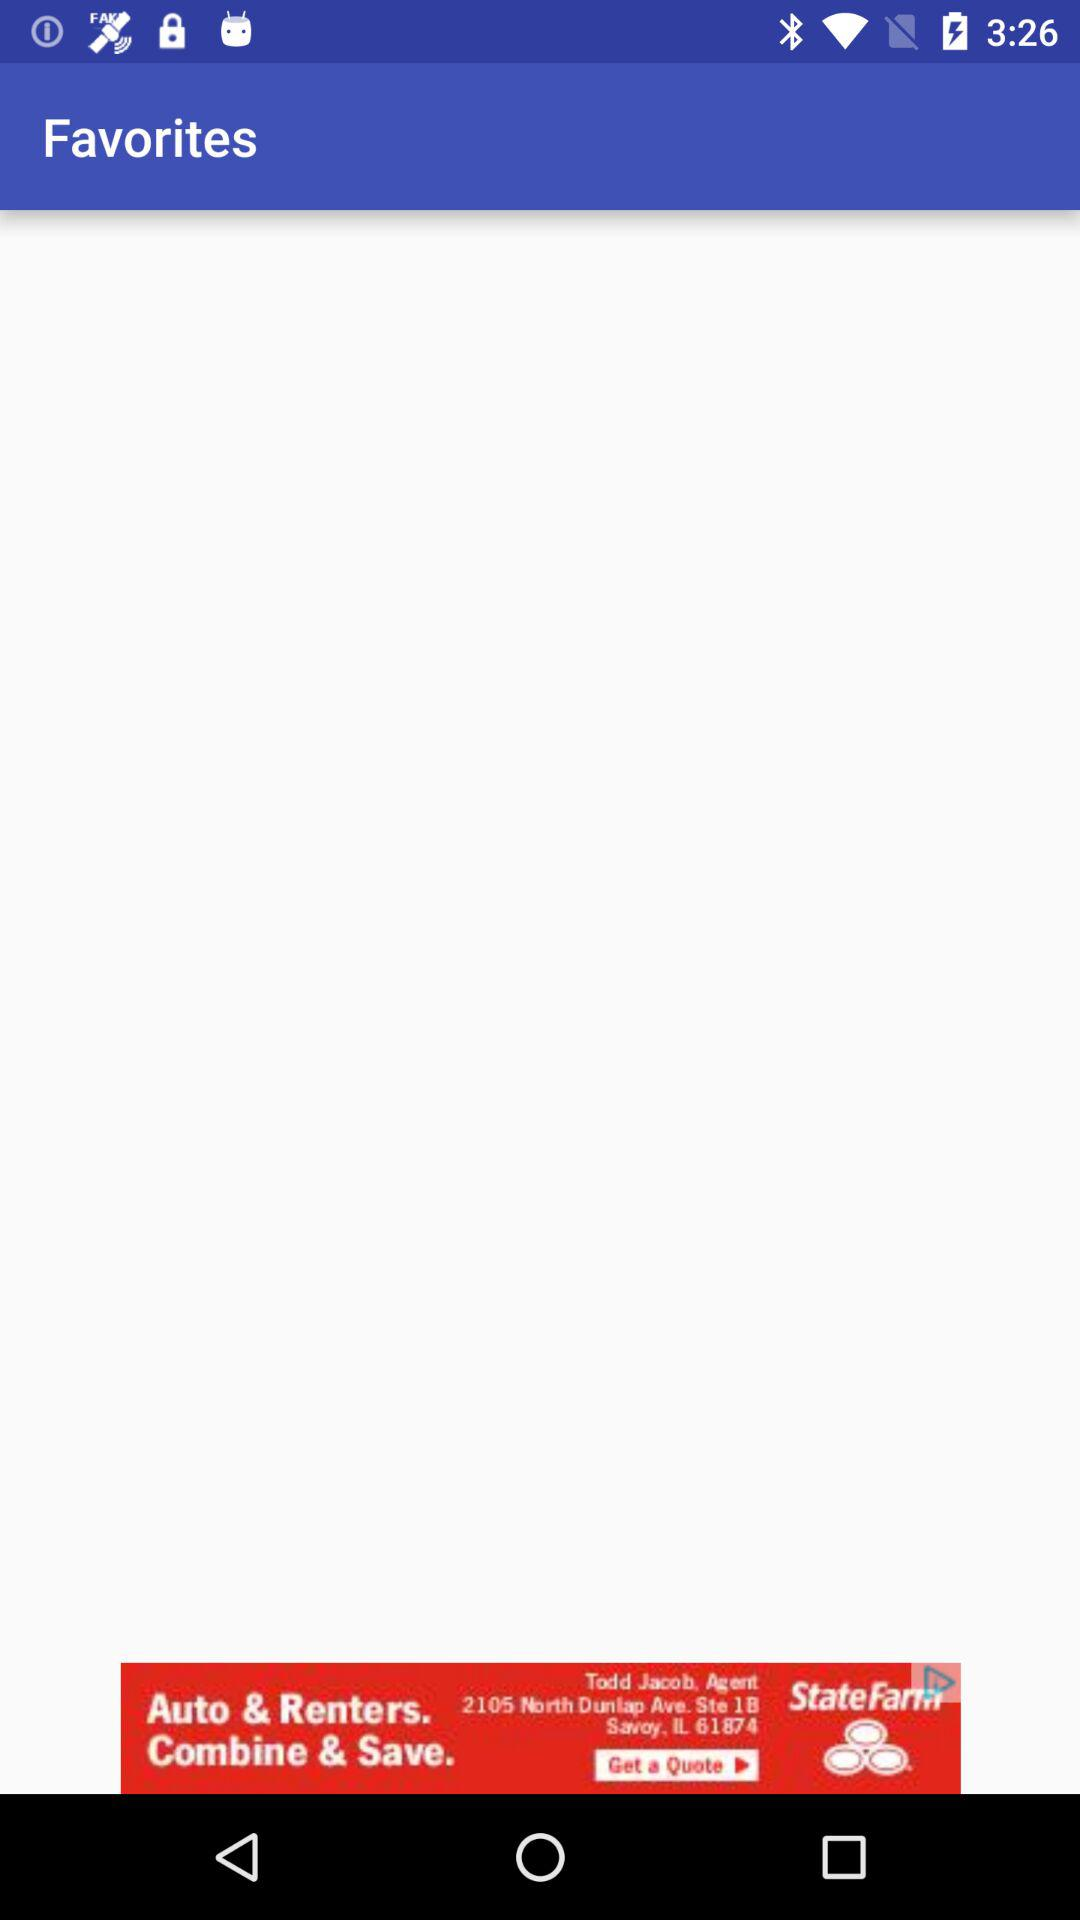What are the available tutorials? The available tutorials are "Top 5 Websites to Master Hacking With Kali Linux", "Kali Linux : Touchpad issues–tapping, reverse/natural scrolling", "SQLMap with Tor for Anonymity", "Hacking WPA/WPA2 without dictionary/bruteforce : Fluxion", "How to hack facebook using kali linux : CREDENTIALS HARVESTER ATTACK", "Antivirus Evasion : Bypassing AV with Veil", and "Hack Any Android Phone : msfvenon–Metasploit payload generator". 